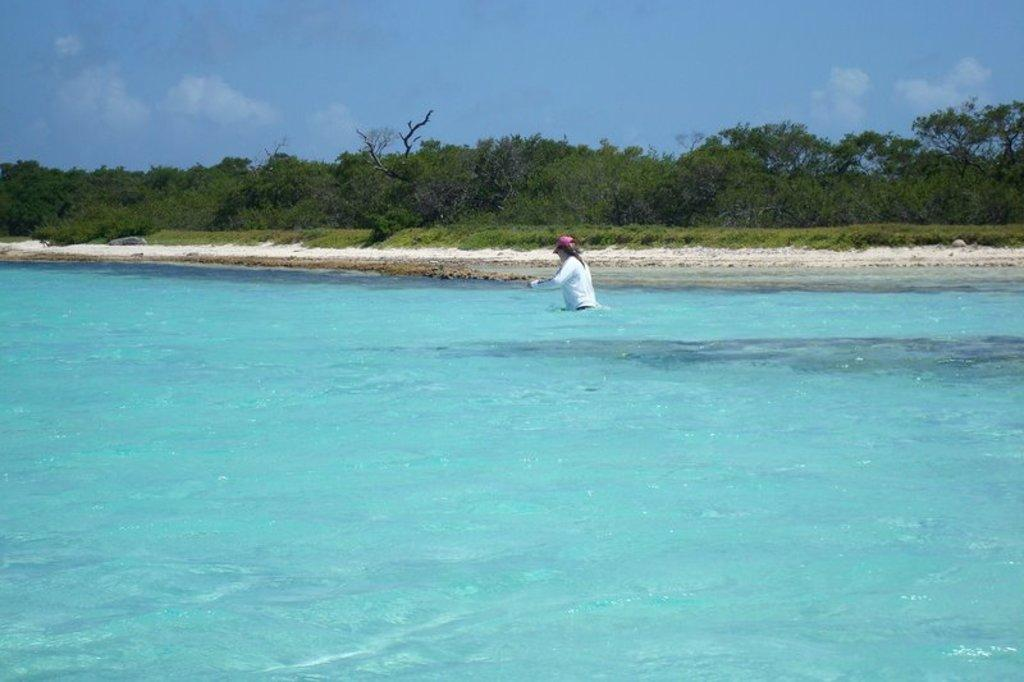What is visible at the bottom of the image? There is water visible at the bottom of the image. What is the person in the image doing? There is a person in the water, which suggests they might be swimming or playing. What can be seen in the background of the image? There are many trees in the background of the image. What is visible at the top of the image? The sky is visible at the top of the image. What can be observed in the sky? Clouds are present in the sky. What type of hair can be seen on the person in the water? There is no information about the person's hair in the image, so it cannot be determined. What territory is being claimed by the trees in the background? There is no indication of territorial claims in the image; the trees are simply part of the background. 